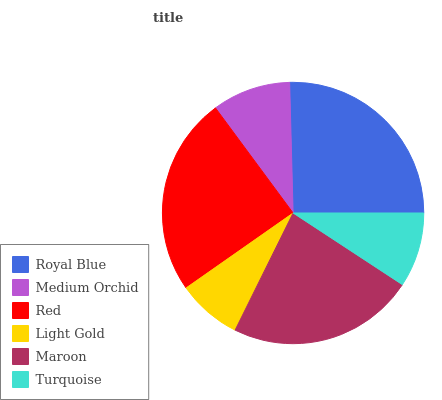Is Light Gold the minimum?
Answer yes or no. Yes. Is Royal Blue the maximum?
Answer yes or no. Yes. Is Medium Orchid the minimum?
Answer yes or no. No. Is Medium Orchid the maximum?
Answer yes or no. No. Is Royal Blue greater than Medium Orchid?
Answer yes or no. Yes. Is Medium Orchid less than Royal Blue?
Answer yes or no. Yes. Is Medium Orchid greater than Royal Blue?
Answer yes or no. No. Is Royal Blue less than Medium Orchid?
Answer yes or no. No. Is Maroon the high median?
Answer yes or no. Yes. Is Medium Orchid the low median?
Answer yes or no. Yes. Is Light Gold the high median?
Answer yes or no. No. Is Red the low median?
Answer yes or no. No. 